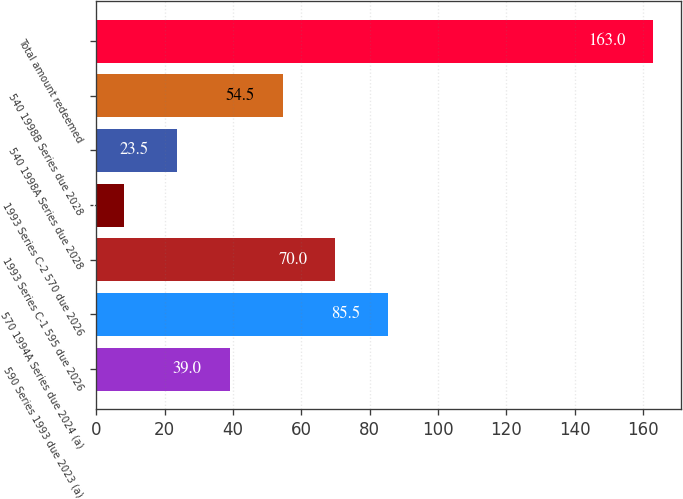Convert chart to OTSL. <chart><loc_0><loc_0><loc_500><loc_500><bar_chart><fcel>590 Series 1993 due 2023 (a)<fcel>570 1994A Series due 2024 (a)<fcel>1993 Series C-1 595 due 2026<fcel>1993 Series C-2 570 due 2026<fcel>540 1998A Series due 2028<fcel>540 1998B Series due 2028<fcel>Total amount redeemed<nl><fcel>39<fcel>85.5<fcel>70<fcel>8<fcel>23.5<fcel>54.5<fcel>163<nl></chart> 